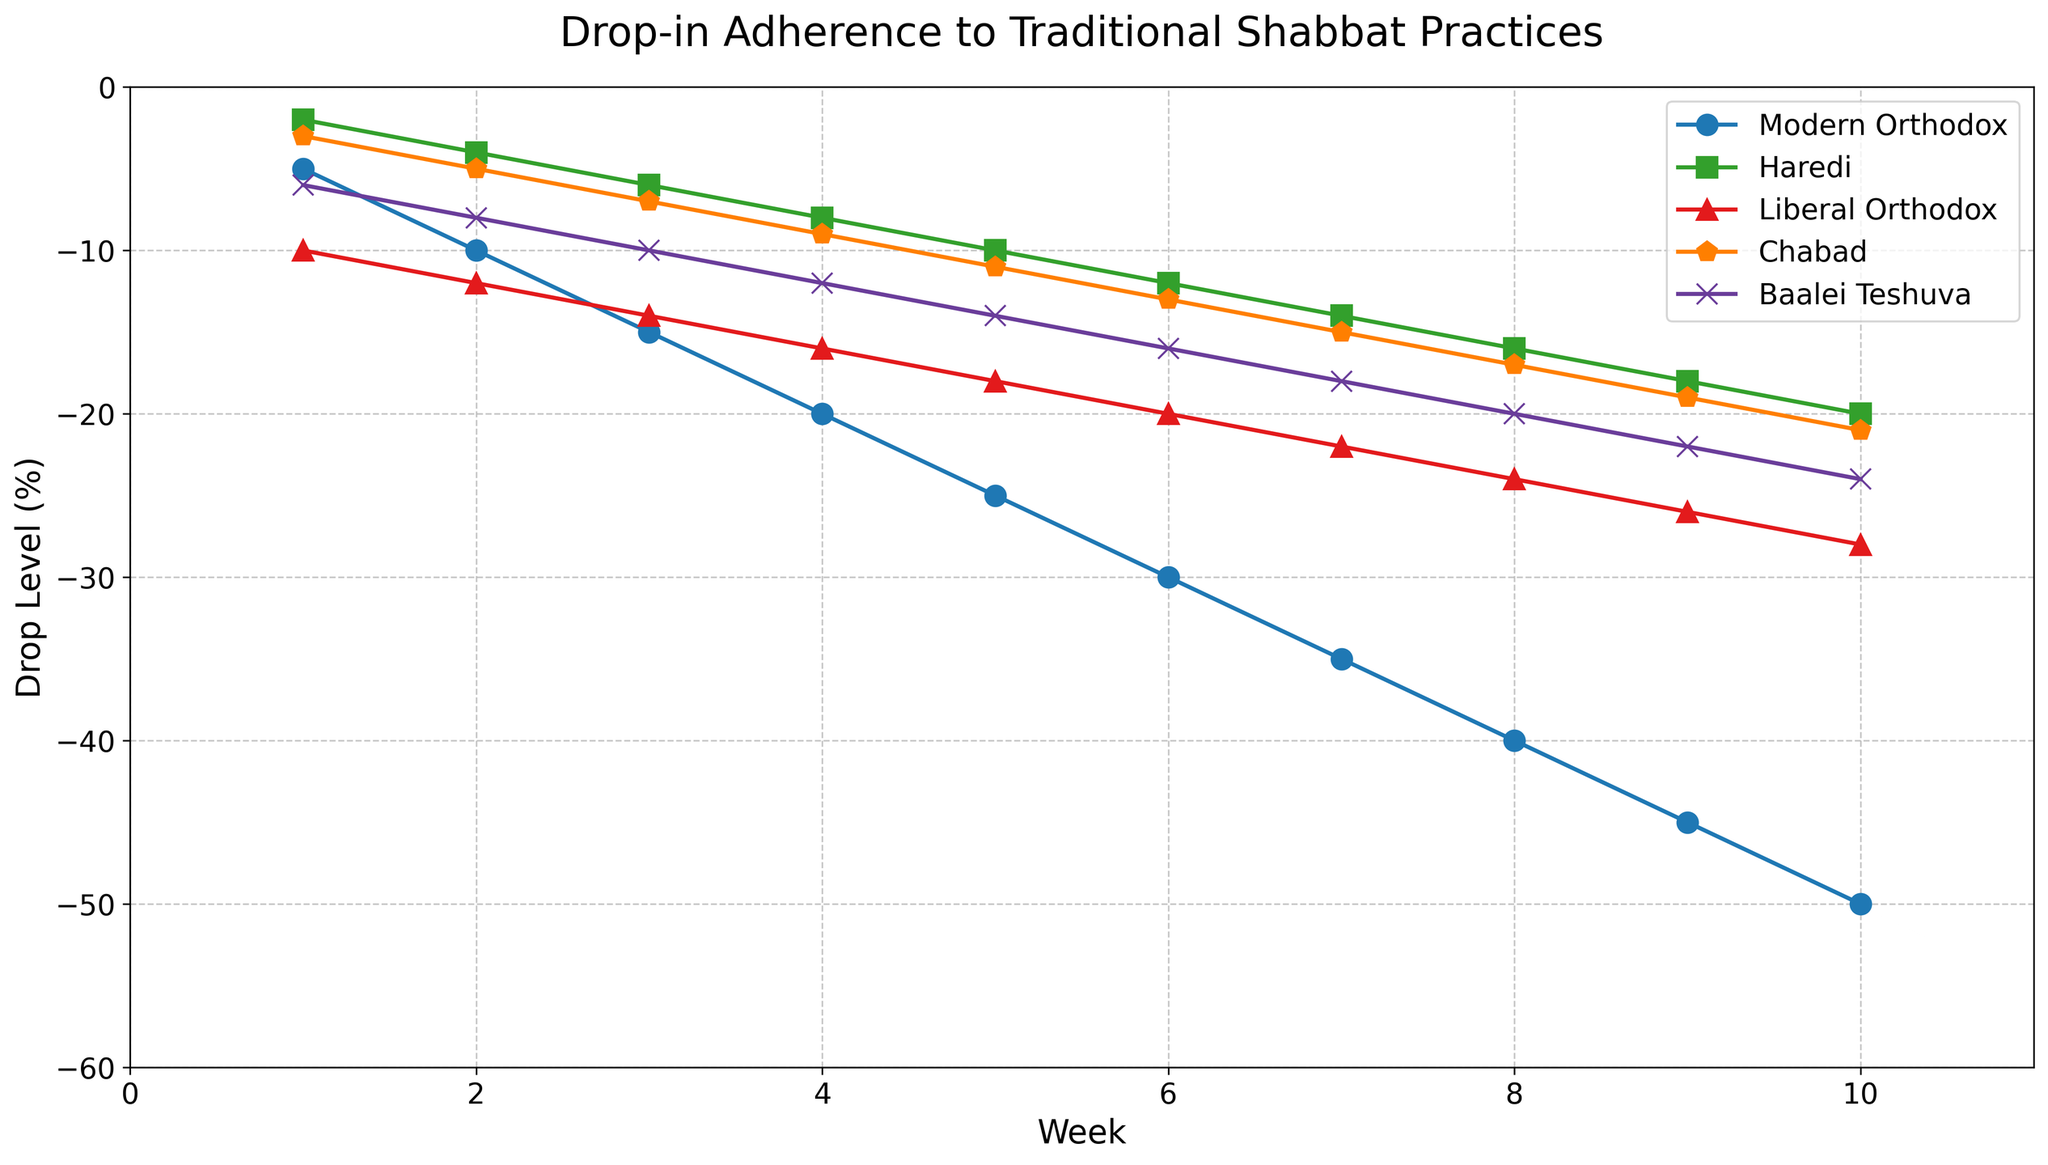Which group experienced the most significant percentage drop in adherence by Week 10? Look for the group with the lowest value in Week 10; it is Modern Orthodox at -50%.
Answer: Modern Orthodox Compare the percentage drop in adherence between the Haredi and Chabad groups in Week 5. Which group had a greater drop? Check the values for Haredi and Chabad in Week 5; Haredi is -10 and Chabad is -11. Chabad has a greater drop.
Answer: Chabad What is the total percentage drop in adherence for the Baalei Teshuva group over 10 weeks? Sum the percentage drop values for Baalei Teshuva from Week 1 to Week 10: -6 + -8 + -10 + -12 + -14 + -16 + -18 + -20 + -22 + -24 = -150.
Answer: -150 Which week shows the smallest difference in adherence drop between the Haredi and Modern Orthodox groups? Calculate the differences in each week and identify the smallest: Week 1 = 3, Week 2 = 6, Week 3 = 9, Week 4 = 12, Week 5 = 15, Week 6 = 18, Week 7 = 21, Week 8 = 24, Week 9 = 27, Week 10 = 30. The smallest difference is in Week 1.
Answer: Week 1 In Week 6, what is the average percentage drop in adherence across all groups? Add the adherence drop percentages in Week 6 and divide by the number of groups: (-30 + -12 + -20 + -13 + -16) / 5 = -91 / 5 = -18.2.
Answer: -18.2 How does the adherence drop in the Liberal Orthodox group in Week 8 compare to that in Week 2? Compare the values for Liberal Orthodox in Week 8 and Week 2: -24 in Week 8, -12 in Week 2. Week 8 has twice the drop compared to Week 2.
Answer: Twice as much in Week 8 What is the increase in the adherence drop for the Modern Orthodox group from Week 3 to Week 7? Calculate the difference in drop from Week 3 to Week 7: -35 - (-15) = -35 + 15 = -20.
Answer: -20 Which group had the least adherence drop in Week 3? Check the values for each group in Week 3 and identify the highest value: Modern Orthodox = -15, Haredi = -6, Liberal Orthodox = -14, Chabad = -7, Baalei Teshuva = -10. Haredi had the least drop at -6.
Answer: Haredi Which color represents the Chabad group's adherence drop trend? Identify the color and marker style associated with the Chabad group from the plot description. The plot description indicates Chabad is represented by the color orange and a pentagon marker.
Answer: Orange 